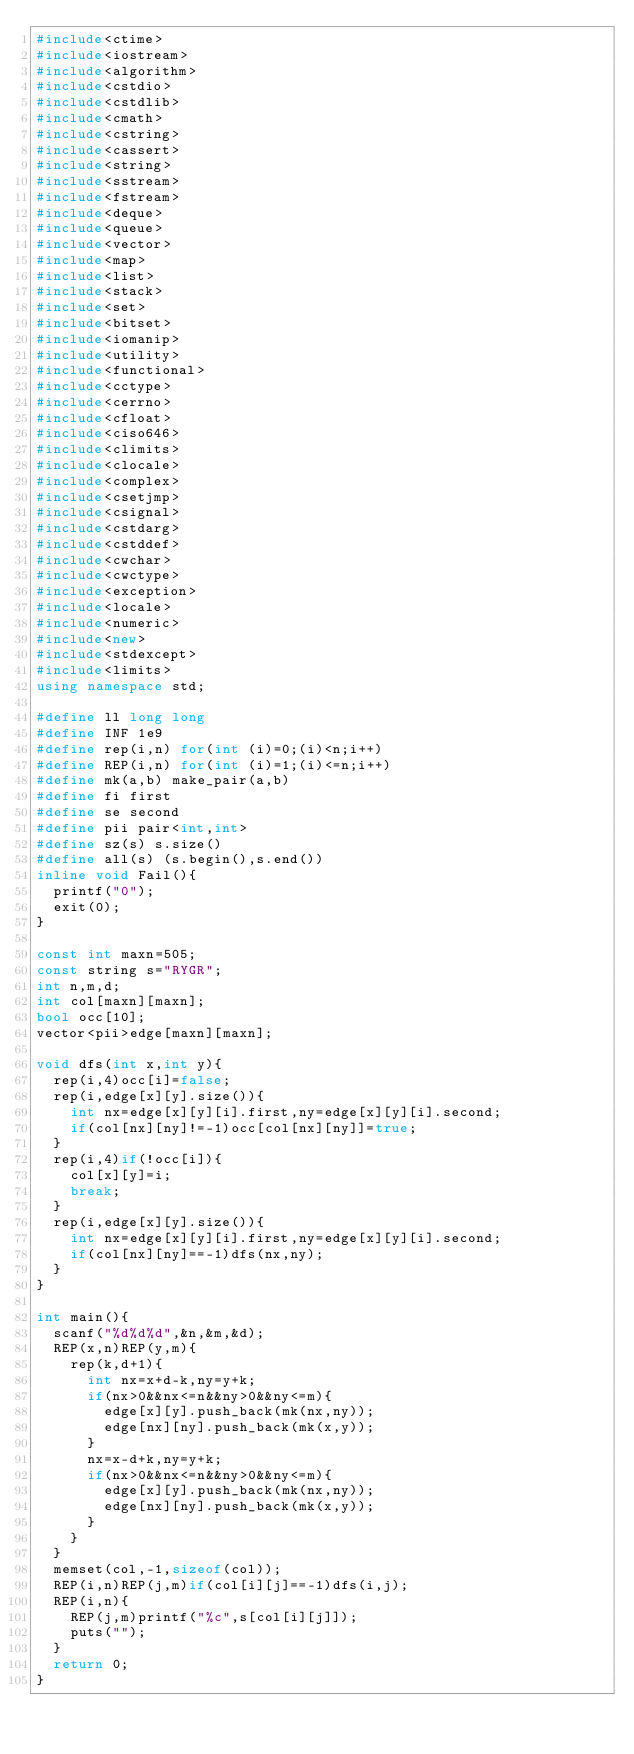Convert code to text. <code><loc_0><loc_0><loc_500><loc_500><_C++_>#include<ctime>
#include<iostream>
#include<algorithm>
#include<cstdio>
#include<cstdlib>
#include<cmath> 
#include<cstring> 
#include<cassert>
#include<string>
#include<sstream>
#include<fstream>
#include<deque>
#include<queue>
#include<vector>
#include<map>
#include<list>
#include<stack>
#include<set>
#include<bitset>
#include<iomanip>
#include<utility>
#include<functional>
#include<cctype>
#include<cerrno>
#include<cfloat>
#include<ciso646>
#include<climits>
#include<clocale>
#include<complex>
#include<csetjmp>
#include<csignal>
#include<cstdarg>
#include<cstddef>
#include<cwchar>
#include<cwctype>
#include<exception>
#include<locale>
#include<numeric>
#include<new>
#include<stdexcept>
#include<limits>
using namespace std;

#define ll long long
#define INF 1e9
#define rep(i,n) for(int (i)=0;(i)<n;i++)
#define REP(i,n) for(int (i)=1;(i)<=n;i++)
#define mk(a,b) make_pair(a,b)
#define fi first
#define se second
#define pii pair<int,int>
#define sz(s) s.size()
#define all(s) (s.begin(),s.end())
inline void Fail(){
	printf("0");
	exit(0);
}

const int maxn=505;
const string s="RYGR";
int n,m,d;
int col[maxn][maxn];
bool occ[10];
vector<pii>edge[maxn][maxn];

void dfs(int x,int y){
	rep(i,4)occ[i]=false;
	rep(i,edge[x][y].size()){
		int nx=edge[x][y][i].first,ny=edge[x][y][i].second;
		if(col[nx][ny]!=-1)occ[col[nx][ny]]=true;
	}
	rep(i,4)if(!occ[i]){
		col[x][y]=i;
		break;
	}
	rep(i,edge[x][y].size()){
		int nx=edge[x][y][i].first,ny=edge[x][y][i].second;
		if(col[nx][ny]==-1)dfs(nx,ny);
	}
} 

int main(){
	scanf("%d%d%d",&n,&m,&d);
	REP(x,n)REP(y,m){
		rep(k,d+1){
			int nx=x+d-k,ny=y+k;
			if(nx>0&&nx<=n&&ny>0&&ny<=m){
				edge[x][y].push_back(mk(nx,ny));
				edge[nx][ny].push_back(mk(x,y));
			}
			nx=x-d+k,ny=y+k;
			if(nx>0&&nx<=n&&ny>0&&ny<=m){
				edge[x][y].push_back(mk(nx,ny));
				edge[nx][ny].push_back(mk(x,y));
			}
		}
	}
	memset(col,-1,sizeof(col));
	REP(i,n)REP(j,m)if(col[i][j]==-1)dfs(i,j);
	REP(i,n){
		REP(j,m)printf("%c",s[col[i][j]]);
		puts("");
	}
	return 0;
}</code> 